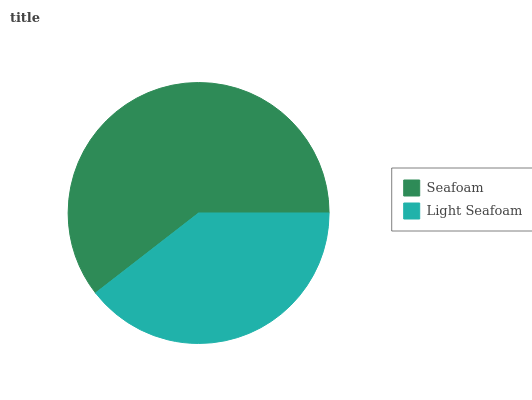Is Light Seafoam the minimum?
Answer yes or no. Yes. Is Seafoam the maximum?
Answer yes or no. Yes. Is Light Seafoam the maximum?
Answer yes or no. No. Is Seafoam greater than Light Seafoam?
Answer yes or no. Yes. Is Light Seafoam less than Seafoam?
Answer yes or no. Yes. Is Light Seafoam greater than Seafoam?
Answer yes or no. No. Is Seafoam less than Light Seafoam?
Answer yes or no. No. Is Seafoam the high median?
Answer yes or no. Yes. Is Light Seafoam the low median?
Answer yes or no. Yes. Is Light Seafoam the high median?
Answer yes or no. No. Is Seafoam the low median?
Answer yes or no. No. 